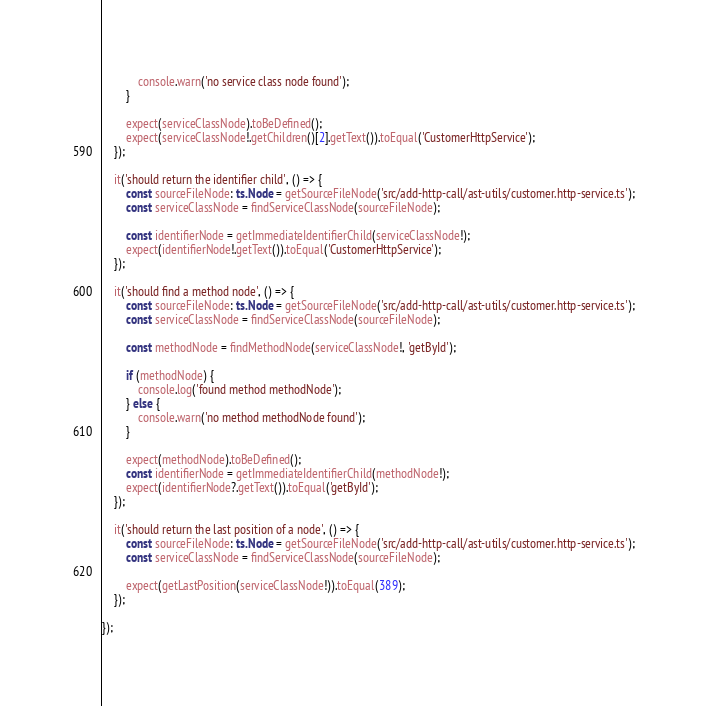Convert code to text. <code><loc_0><loc_0><loc_500><loc_500><_TypeScript_>            console.warn('no service class node found');
        }

        expect(serviceClassNode).toBeDefined();
        expect(serviceClassNode!.getChildren()[2].getText()).toEqual('CustomerHttpService');
    });

    it('should return the identifier child', () => {
        const sourceFileNode: ts.Node = getSourceFileNode('src/add-http-call/ast-utils/customer.http-service.ts');
        const serviceClassNode = findServiceClassNode(sourceFileNode);

        const identifierNode = getImmediateIdentifierChild(serviceClassNode!);
        expect(identifierNode!.getText()).toEqual('CustomerHttpService');
    });

    it('should find a method node', () => {
        const sourceFileNode: ts.Node = getSourceFileNode('src/add-http-call/ast-utils/customer.http-service.ts');
        const serviceClassNode = findServiceClassNode(sourceFileNode);

        const methodNode = findMethodNode(serviceClassNode!, 'getById');

        if (methodNode) {
            console.log('found method methodNode');
        } else {
            console.warn('no method methodNode found');
        }

        expect(methodNode).toBeDefined();
        const identifierNode = getImmediateIdentifierChild(methodNode!);
        expect(identifierNode?.getText()).toEqual('getById');
    });

    it('should return the last position of a node', () => {
        const sourceFileNode: ts.Node = getSourceFileNode('src/add-http-call/ast-utils/customer.http-service.ts');
        const serviceClassNode = findServiceClassNode(sourceFileNode);

        expect(getLastPosition(serviceClassNode!)).toEqual(389);
    });

});
</code> 